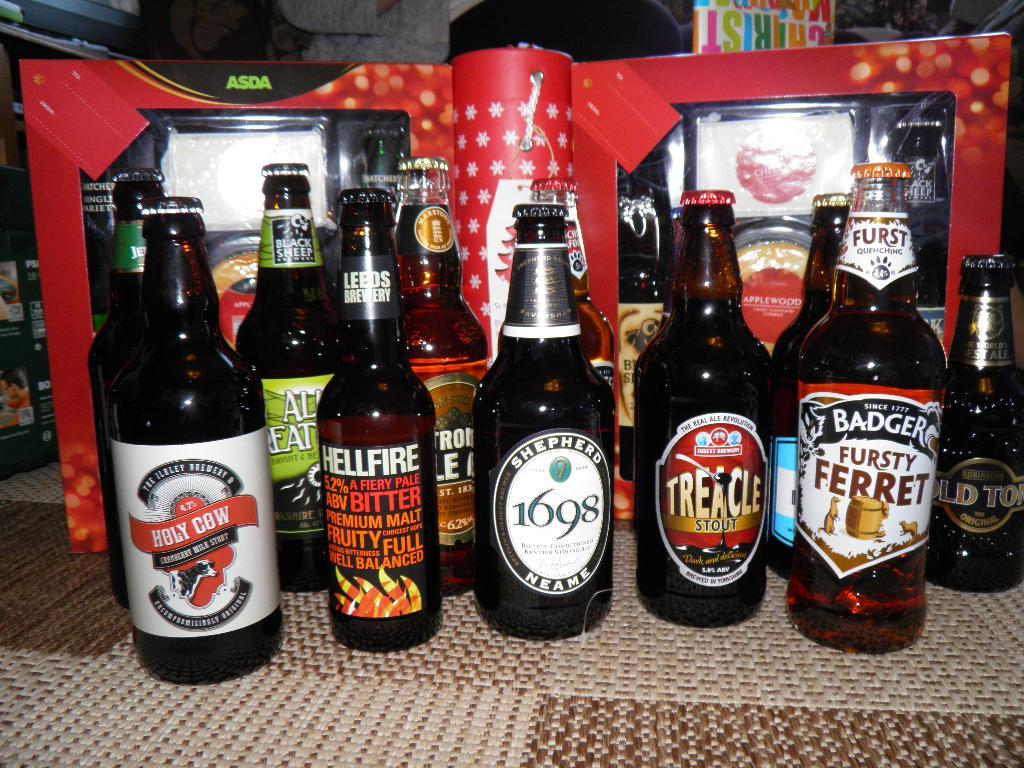<image>
Present a compact description of the photo's key features. Different bottles of beer are arranged on carpet tiles, including one called Holy Cow. 